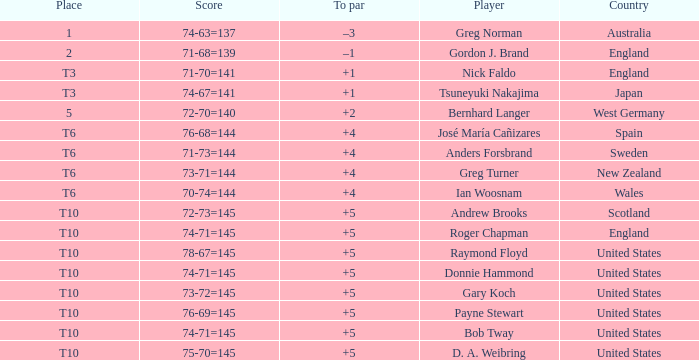What country did Raymond Floyd play for? United States. 